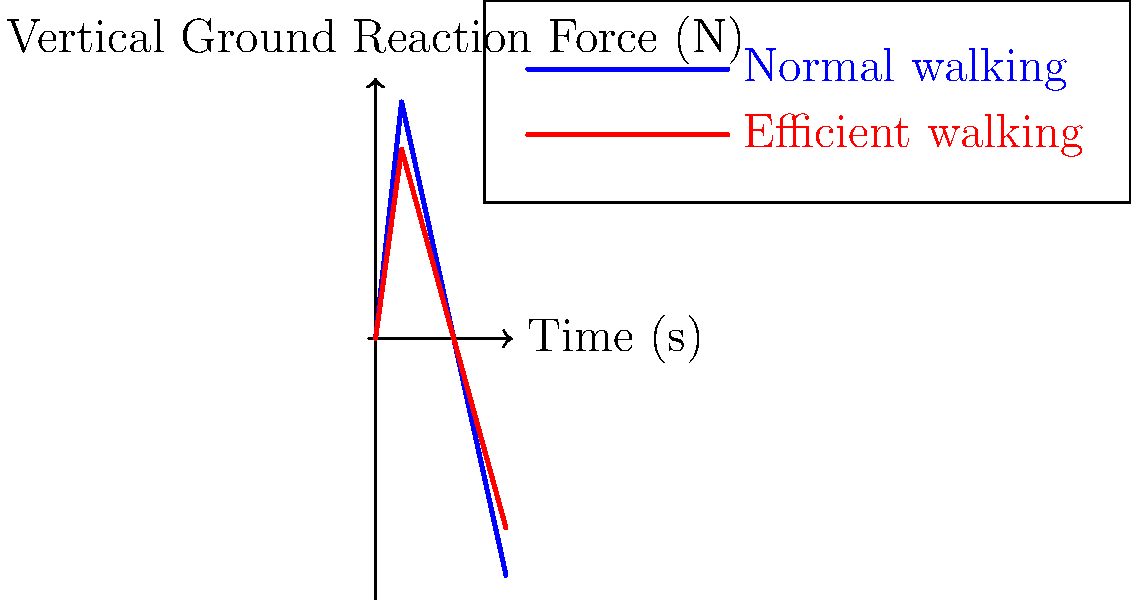Based on the force plate data graphs shown, which walking style appears to be more biomechanically efficient, and how does this relate to data protection concerns in fitness tracking devices? To answer this question, we need to analyze the graph and consider its implications for data protection:

1. Graph analysis:
   - The blue line represents normal walking, while the red line represents efficient walking.
   - Both lines show a similar pattern, but the red line (efficient walking) has lower peak forces.
   - Lower peak forces generally indicate less energy expenditure and better shock absorption.

2. Biomechanical efficiency:
   - The efficient walking style (red line) shows lower amplitude in vertical ground reaction forces.
   - This suggests that the efficient style requires less energy to maintain and puts less stress on the joints.
   - Lower force peaks also indicate better distribution of forces over time, which is typically more efficient.

3. Data protection concerns:
   - Modern fitness tracking devices often collect detailed biomechanical data, including walking patterns.
   - This type of data can be considered sensitive personal information, as it can reveal:
     a) An individual's physical condition and potential health issues.
     b) Unique identifiable patterns (gait analysis) that could be used for surveillance.
   - The collection and storage of such detailed biomechanical data raise privacy concerns:
     a) Who has access to this data?
     b) How is it stored and protected?
     c) What are the potential implications if this data is breached or misused?

4. Relation to German data protection laws:
   - Germany has strict data protection laws under the GDPR (General Data Protection Regulation).
   - Collection of biomechanical data would likely require explicit consent and clear explanations of data usage.
   - Companies collecting such data would need to implement strong security measures to protect it.

5. Ethical considerations:
   - While this data can be useful for improving health and fitness, it also poses risks to individual privacy.
   - There's a need for balanced regulations that allow for technological advancements while protecting personal data.

In conclusion, the efficient walking style appears more biomechanically efficient due to lower peak forces. However, the collection of such detailed biomechanical data by fitness devices raises significant data protection concerns, especially in a privacy-conscious country like Germany.
Answer: Efficient walking; raises privacy concerns due to detailed personal data collection. 